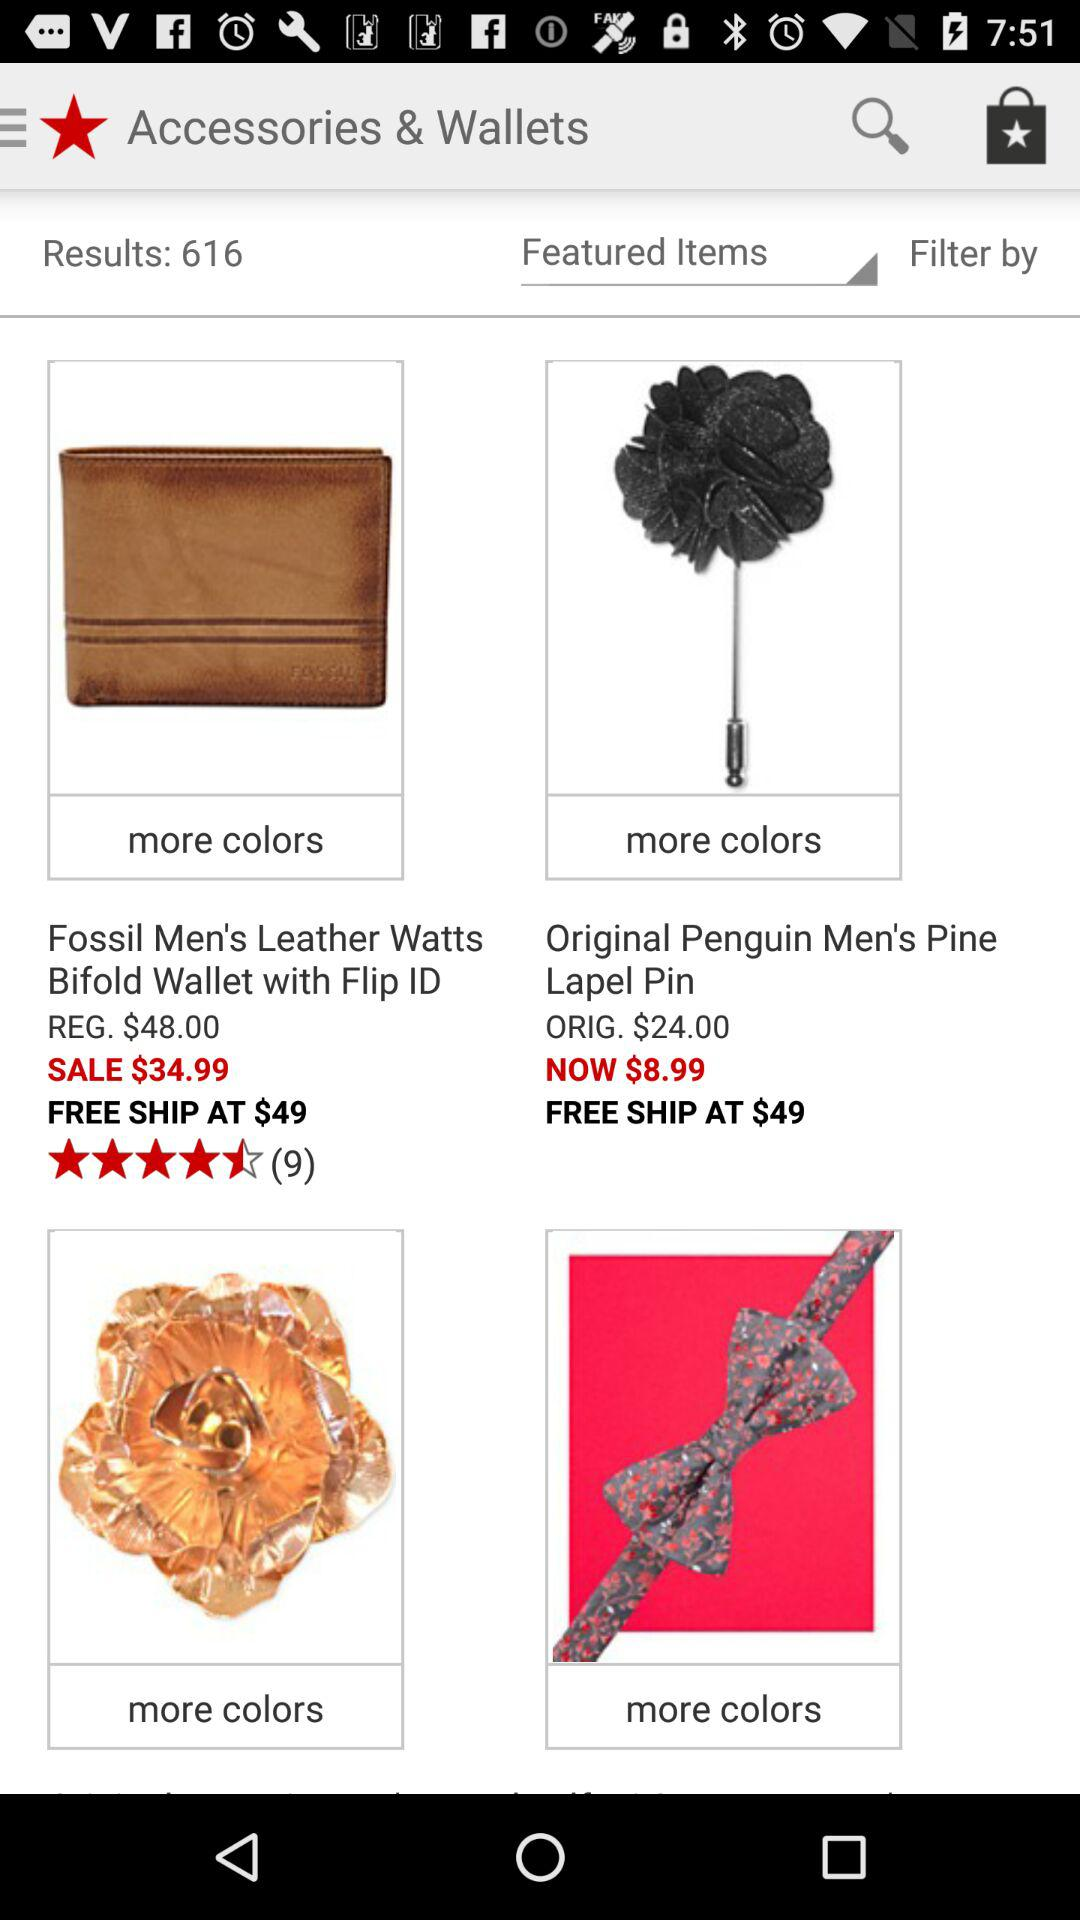What is the rating of "Men's Bifold Wallet"? The rating is 4.5 stars. 